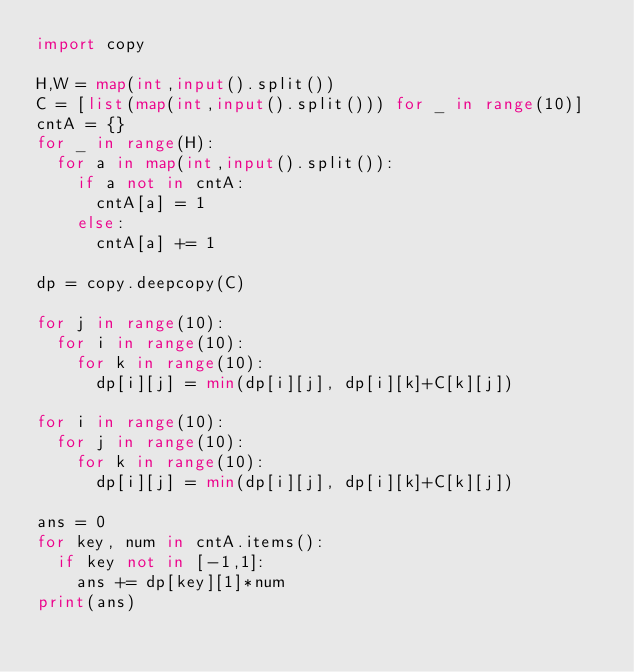Convert code to text. <code><loc_0><loc_0><loc_500><loc_500><_Python_>import copy

H,W = map(int,input().split())
C = [list(map(int,input().split())) for _ in range(10)]
cntA = {}
for _ in range(H):
  for a in map(int,input().split()):
    if a not in cntA:
      cntA[a] = 1
    else:
      cntA[a] += 1

dp = copy.deepcopy(C)

for j in range(10):
  for i in range(10):
    for k in range(10):
      dp[i][j] = min(dp[i][j], dp[i][k]+C[k][j])

for i in range(10):
  for j in range(10):
    for k in range(10):
      dp[i][j] = min(dp[i][j], dp[i][k]+C[k][j])
      
ans = 0
for key, num in cntA.items():
  if key not in [-1,1]:
    ans += dp[key][1]*num
print(ans)</code> 